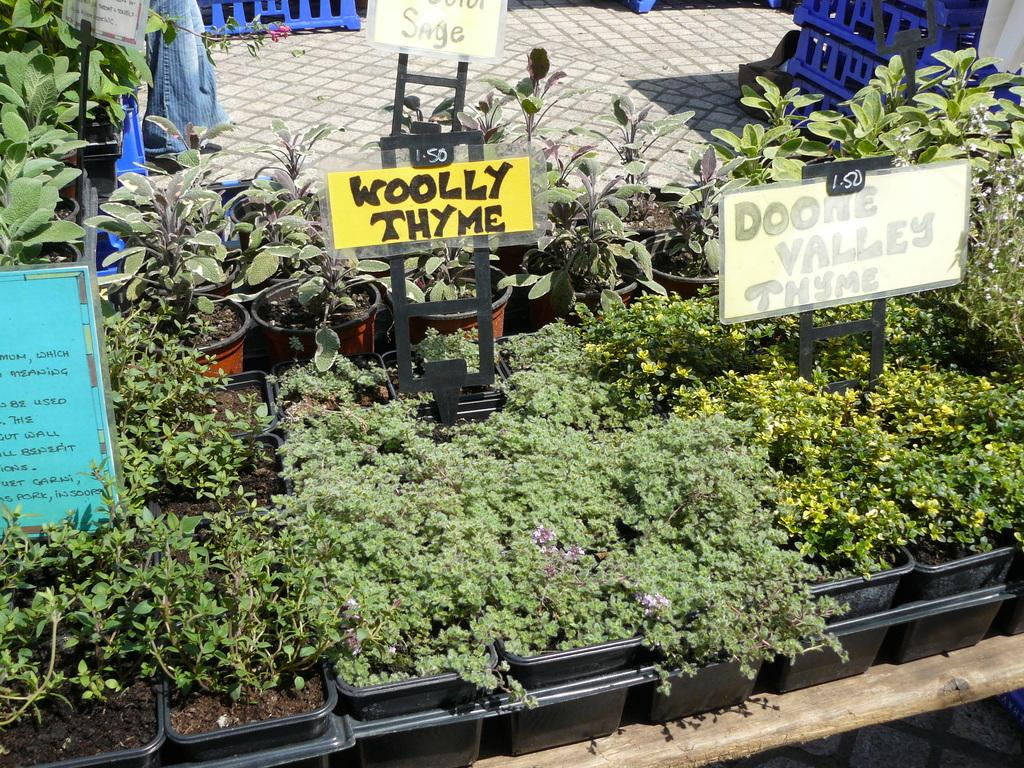What type of plants can be seen in the image? There are plants in flower pots in the image. What can be used to provide information or guidance in the image? There are information boards in the image. What surface is visible beneath the plants and information boards? The floor is visible in the image. What structure can be seen separating or enclosing different areas in the image? There is a fence in the image. Can you see a yak grazing near the plants in the image? No, there is no yak present in the image. Is there a boat docked near the fence in the image? No, there is no boat present in the image. 